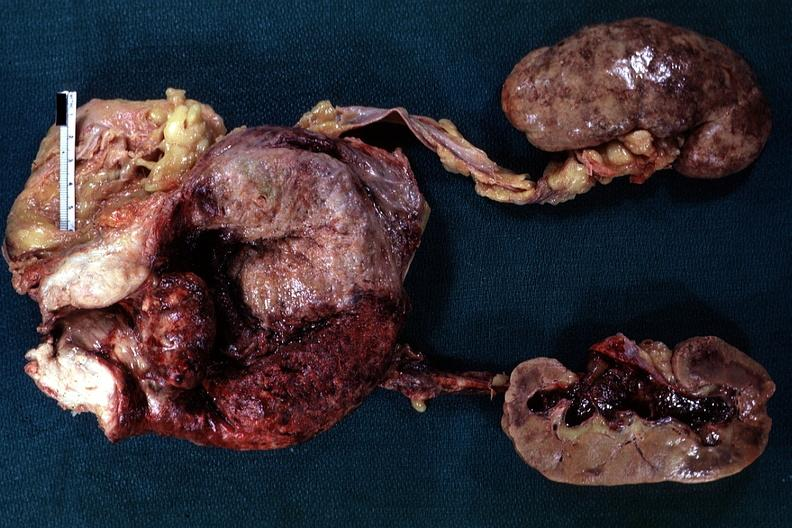what is present?
Answer the question using a single word or phrase. Prostate 